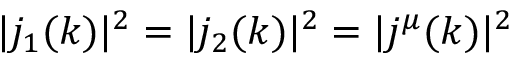Convert formula to latex. <formula><loc_0><loc_0><loc_500><loc_500>| j _ { 1 } ( k ) | ^ { 2 } = | j _ { 2 } ( k ) | ^ { 2 } = | j ^ { \mu } ( k ) | ^ { 2 }</formula> 